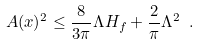<formula> <loc_0><loc_0><loc_500><loc_500>A ( x ) ^ { 2 } \leq \frac { 8 } { 3 \pi } \Lambda H _ { f } + \frac { 2 } { \pi } \Lambda ^ { 2 } \ .</formula> 